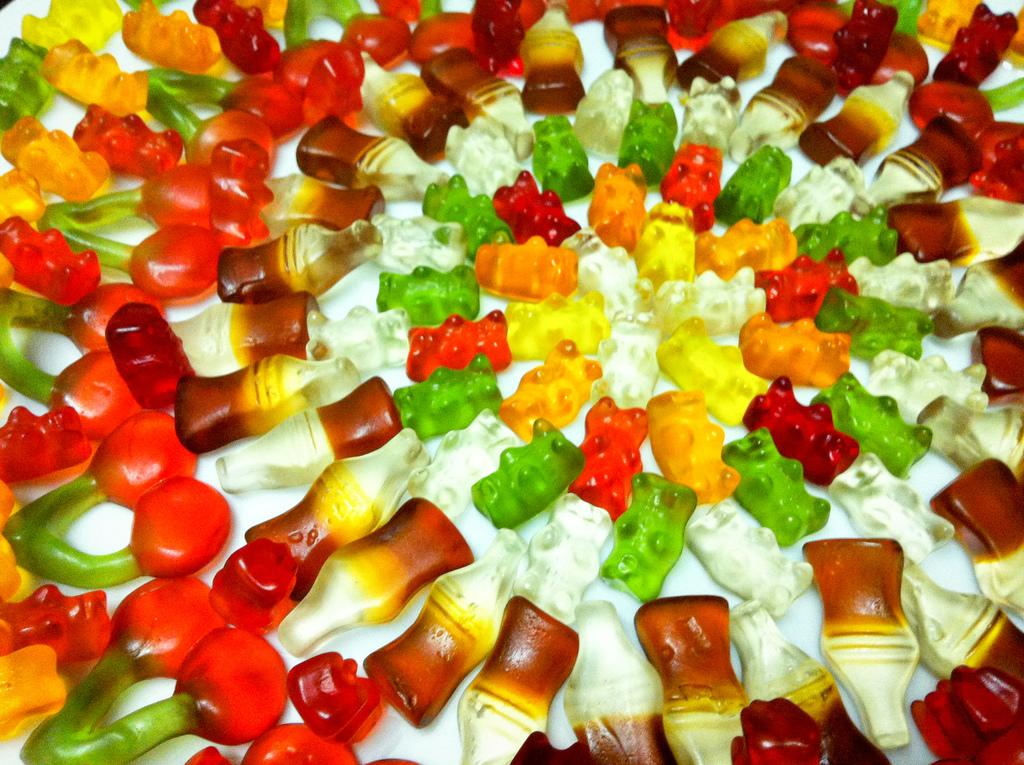What types of food are present in the image? There are different types of jellies in the image. Where is the nest located in the image? There is no nest present in the image. How many cows are visible in the image? There are no cows visible in the image. 